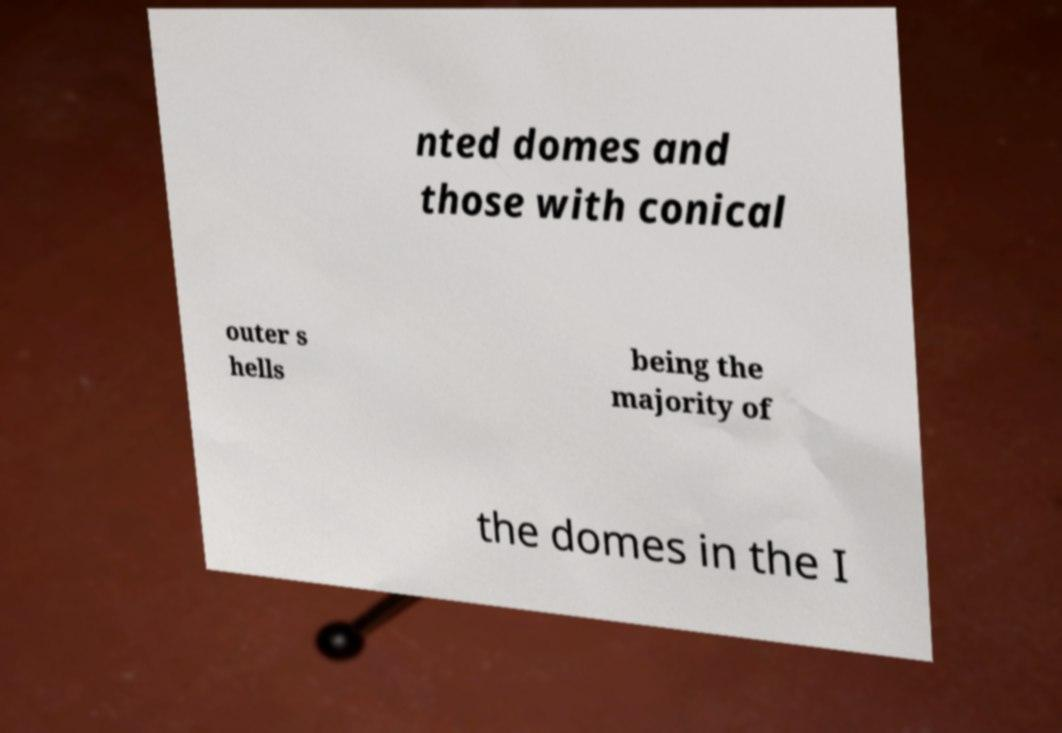Could you assist in decoding the text presented in this image and type it out clearly? nted domes and those with conical outer s hells being the majority of the domes in the I 